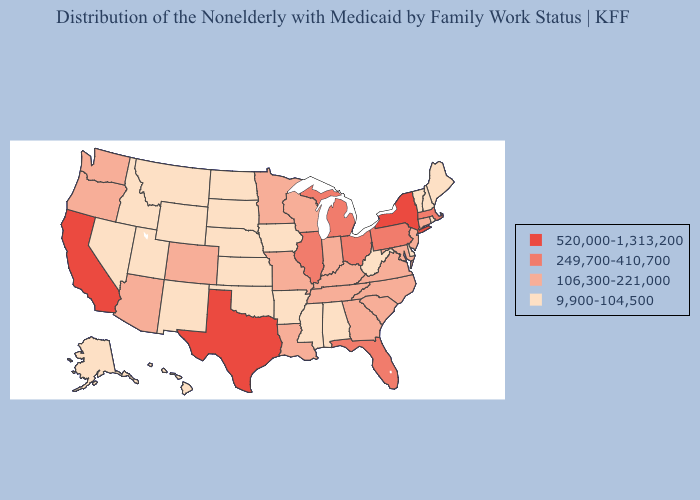Which states have the lowest value in the USA?
Quick response, please. Alabama, Alaska, Arkansas, Delaware, Hawaii, Idaho, Iowa, Kansas, Maine, Mississippi, Montana, Nebraska, Nevada, New Hampshire, New Mexico, North Dakota, Oklahoma, Rhode Island, South Dakota, Utah, Vermont, West Virginia, Wyoming. Does Georgia have a lower value than Texas?
Keep it brief. Yes. Name the states that have a value in the range 520,000-1,313,200?
Write a very short answer. California, New York, Texas. Does Indiana have a lower value than Delaware?
Give a very brief answer. No. What is the value of South Dakota?
Be succinct. 9,900-104,500. Which states have the lowest value in the MidWest?
Concise answer only. Iowa, Kansas, Nebraska, North Dakota, South Dakota. What is the highest value in the USA?
Quick response, please. 520,000-1,313,200. Does Nebraska have the lowest value in the USA?
Concise answer only. Yes. What is the lowest value in states that border New Hampshire?
Keep it brief. 9,900-104,500. Which states hav the highest value in the Northeast?
Keep it brief. New York. Is the legend a continuous bar?
Short answer required. No. Is the legend a continuous bar?
Quick response, please. No. Does the first symbol in the legend represent the smallest category?
Answer briefly. No. What is the value of Alabama?
Keep it brief. 9,900-104,500. Name the states that have a value in the range 520,000-1,313,200?
Be succinct. California, New York, Texas. 